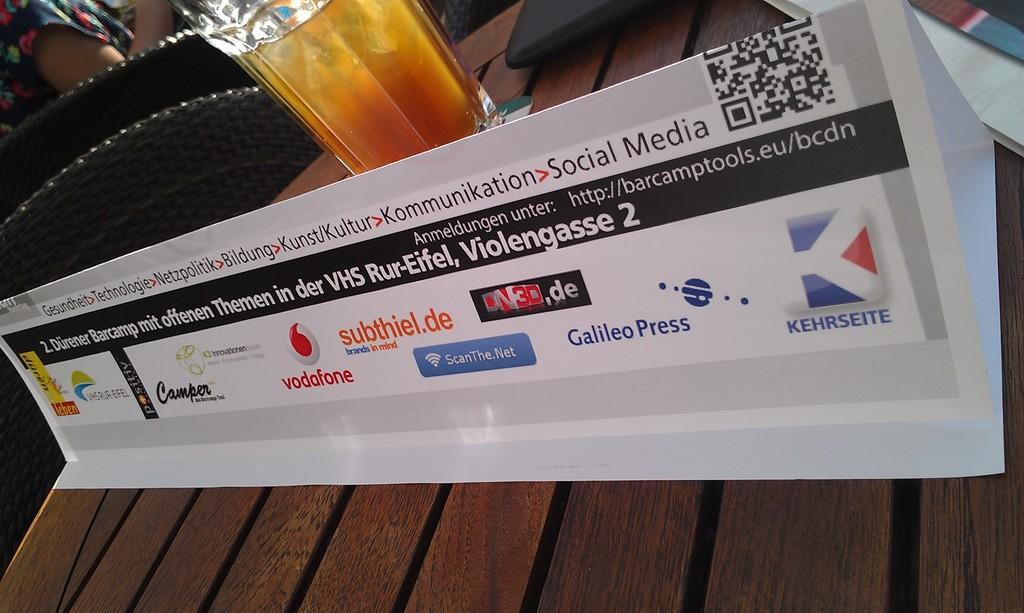Provide a one-sentence caption for the provided image. A white placard bearing business names such as vodafone sits in front of a glass of amber liquid on a wood table.. 